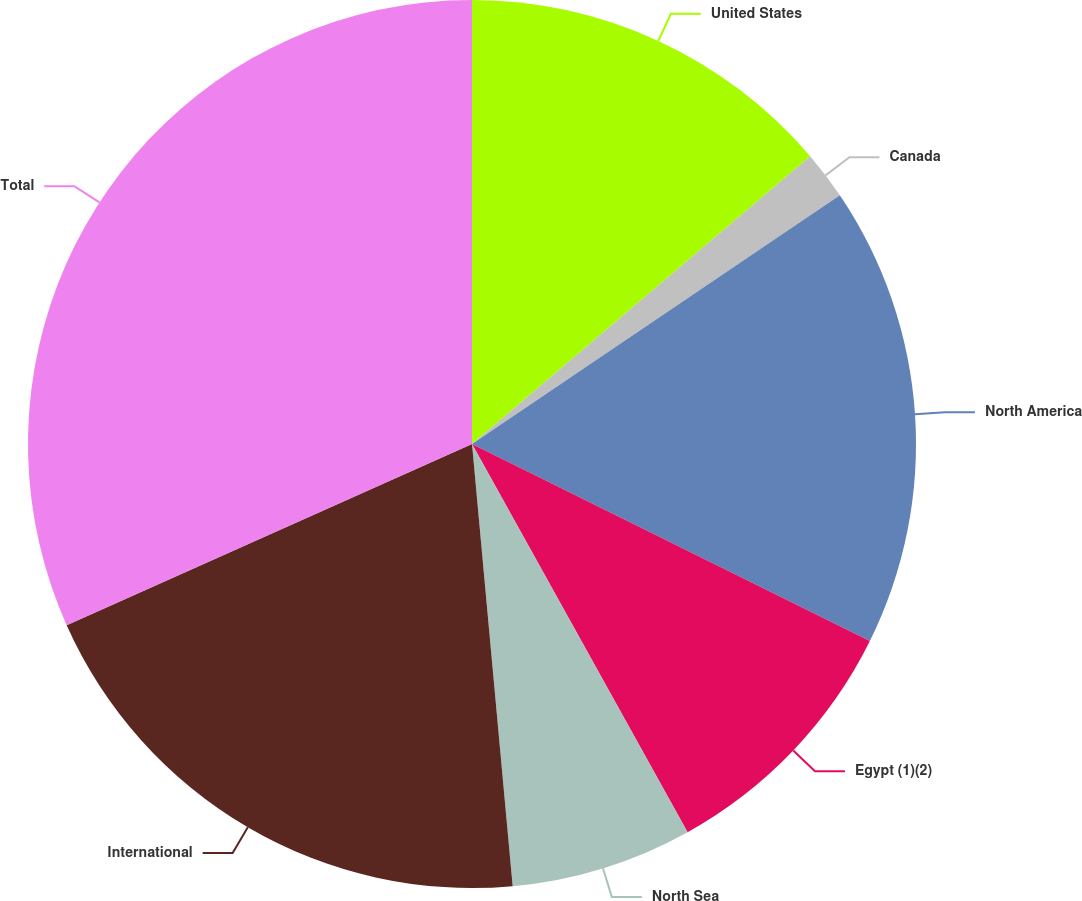Convert chart to OTSL. <chart><loc_0><loc_0><loc_500><loc_500><pie_chart><fcel>United States<fcel>Canada<fcel>North America<fcel>Egypt (1)(2)<fcel>North Sea<fcel>International<fcel>Total<nl><fcel>13.78%<fcel>1.76%<fcel>16.78%<fcel>9.61%<fcel>6.61%<fcel>19.77%<fcel>31.69%<nl></chart> 